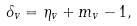Convert formula to latex. <formula><loc_0><loc_0><loc_500><loc_500>\delta _ { v } = \eta _ { v } + m _ { v } - 1 ,</formula> 